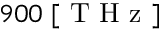Convert formula to latex. <formula><loc_0><loc_0><loc_500><loc_500>9 0 0 \, [ T H z ]</formula> 